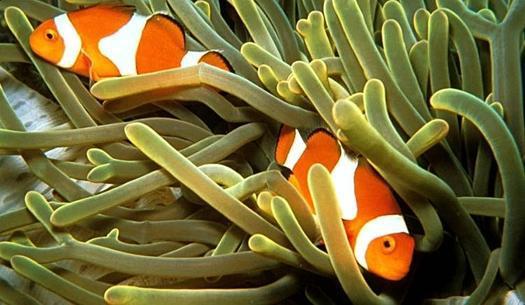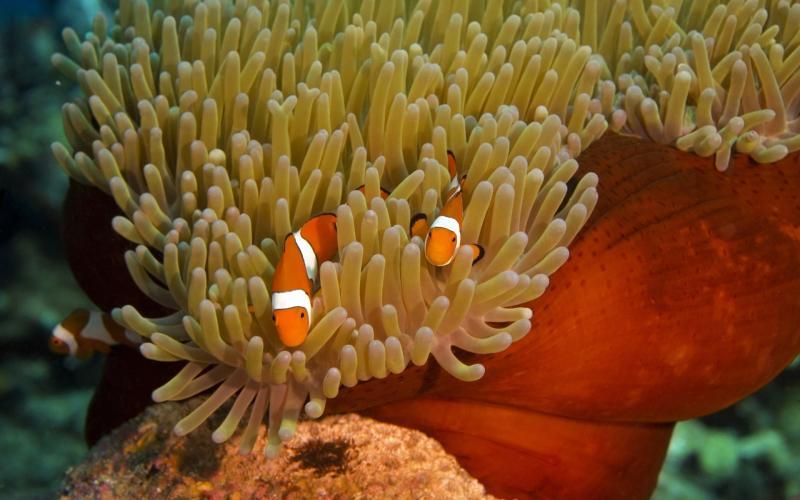The first image is the image on the left, the second image is the image on the right. For the images displayed, is the sentence "There are exactly two clownfish in the right image." factually correct? Answer yes or no. Yes. The first image is the image on the left, the second image is the image on the right. Considering the images on both sides, is "One image shows two fish in anemone tendrils that emerge from a dark-orangish """"stalk""""." valid? Answer yes or no. Yes. 